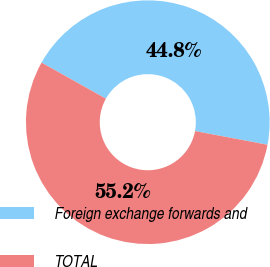<chart> <loc_0><loc_0><loc_500><loc_500><pie_chart><fcel>Foreign exchange forwards and<fcel>TOTAL<nl><fcel>44.83%<fcel>55.17%<nl></chart> 